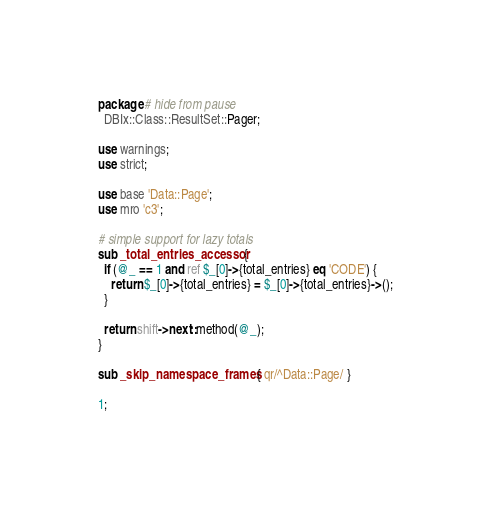Convert code to text. <code><loc_0><loc_0><loc_500><loc_500><_Perl_>package # hide from pause
  DBIx::Class::ResultSet::Pager;

use warnings;
use strict;

use base 'Data::Page';
use mro 'c3';

# simple support for lazy totals
sub _total_entries_accessor {
  if (@_ == 1 and ref $_[0]->{total_entries} eq 'CODE') {
    return $_[0]->{total_entries} = $_[0]->{total_entries}->();
  }

  return shift->next::method(@_);
}

sub _skip_namespace_frames { qr/^Data::Page/ }

1;
</code> 